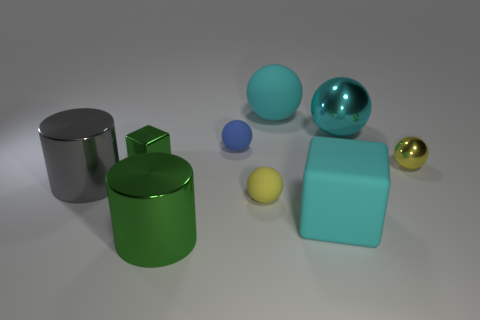Subtract all purple cylinders. How many cyan spheres are left? 2 Subtract all blue spheres. How many spheres are left? 4 Subtract all big cyan matte spheres. How many spheres are left? 4 Subtract 3 spheres. How many spheres are left? 2 Add 1 big rubber things. How many objects exist? 10 Subtract all brown spheres. Subtract all yellow cylinders. How many spheres are left? 5 Subtract all cylinders. How many objects are left? 7 Subtract 0 cyan cylinders. How many objects are left? 9 Subtract all small yellow matte balls. Subtract all small things. How many objects are left? 4 Add 9 blue matte balls. How many blue matte balls are left? 10 